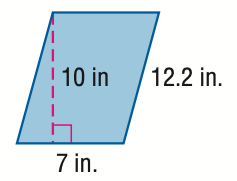Answer the mathemtical geometry problem and directly provide the correct option letter.
Question: Find the perimeter of the parallelogram. Round to the nearest tenth if necessary.
Choices: A: 19.2 B: 38.4 C: 70.0 D: 76.8 B 